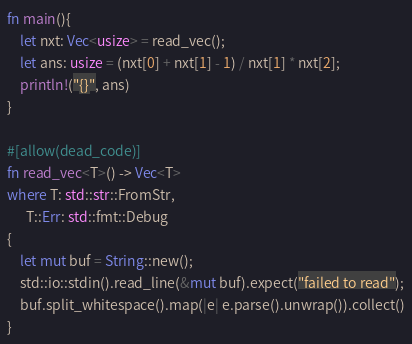Convert code to text. <code><loc_0><loc_0><loc_500><loc_500><_Rust_>fn main(){
    let nxt: Vec<usize> = read_vec();
    let ans: usize = (nxt[0] + nxt[1] - 1) / nxt[1] * nxt[2];
    println!("{}", ans)
}

#[allow(dead_code)]
fn read_vec<T>() -> Vec<T>
where T: std::str::FromStr,
      T::Err: std::fmt::Debug
{
    let mut buf = String::new();
    std::io::stdin().read_line(&mut buf).expect("failed to read");
    buf.split_whitespace().map(|e| e.parse().unwrap()).collect()
}
</code> 